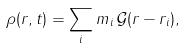<formula> <loc_0><loc_0><loc_500><loc_500>\rho ( { r } , t ) = \sum _ { i } m _ { i } \, { \mathcal { G } } ( { r } - { r _ { i } } ) ,</formula> 